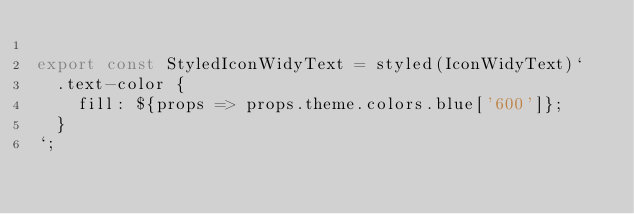Convert code to text. <code><loc_0><loc_0><loc_500><loc_500><_JavaScript_>
export const StyledIconWidyText = styled(IconWidyText)`
  .text-color {
    fill: ${props => props.theme.colors.blue['600']};
  }
`;
</code> 